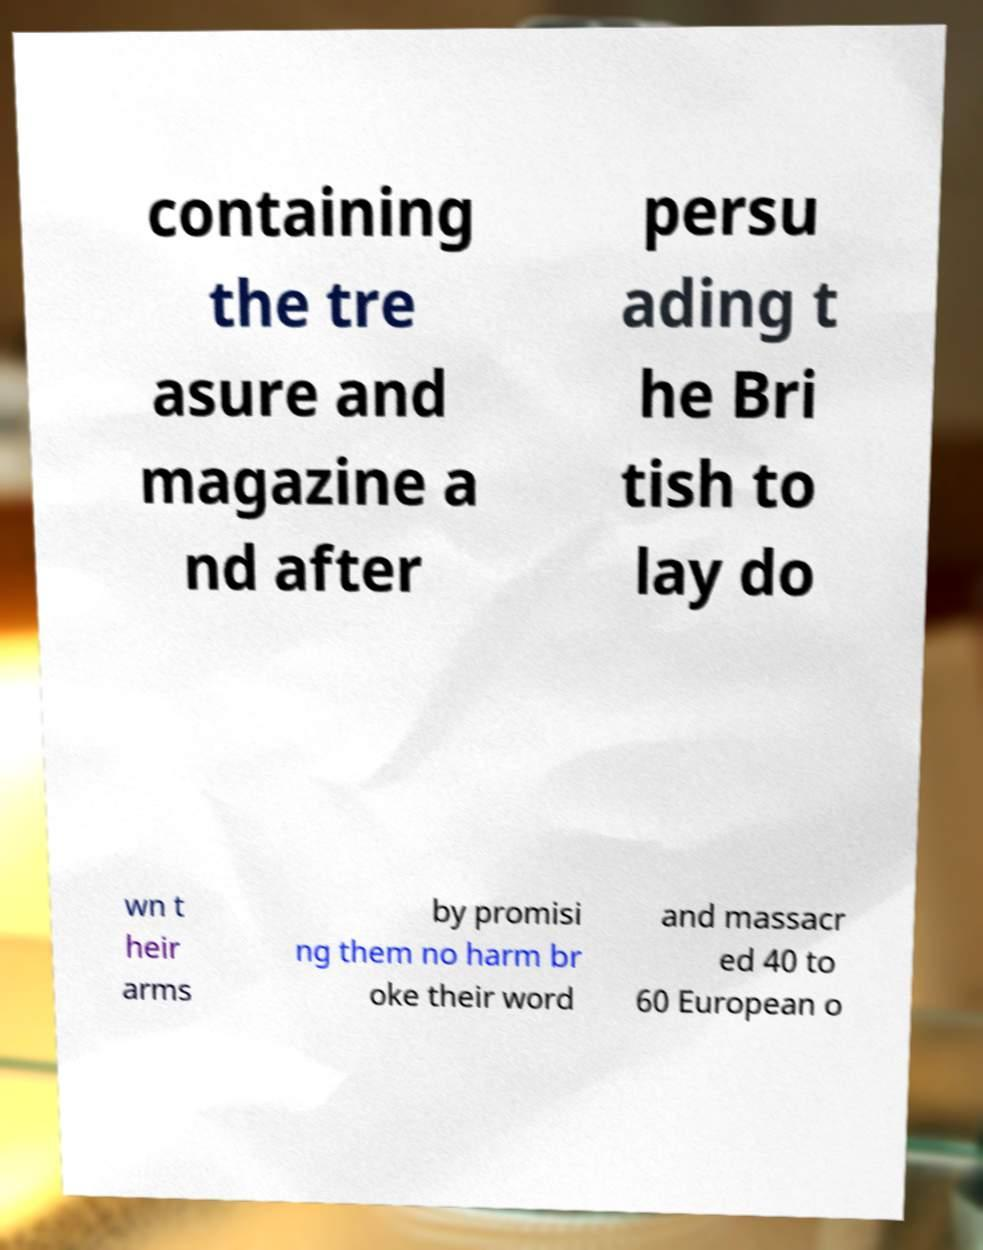Please read and relay the text visible in this image. What does it say? containing the tre asure and magazine a nd after persu ading t he Bri tish to lay do wn t heir arms by promisi ng them no harm br oke their word and massacr ed 40 to 60 European o 